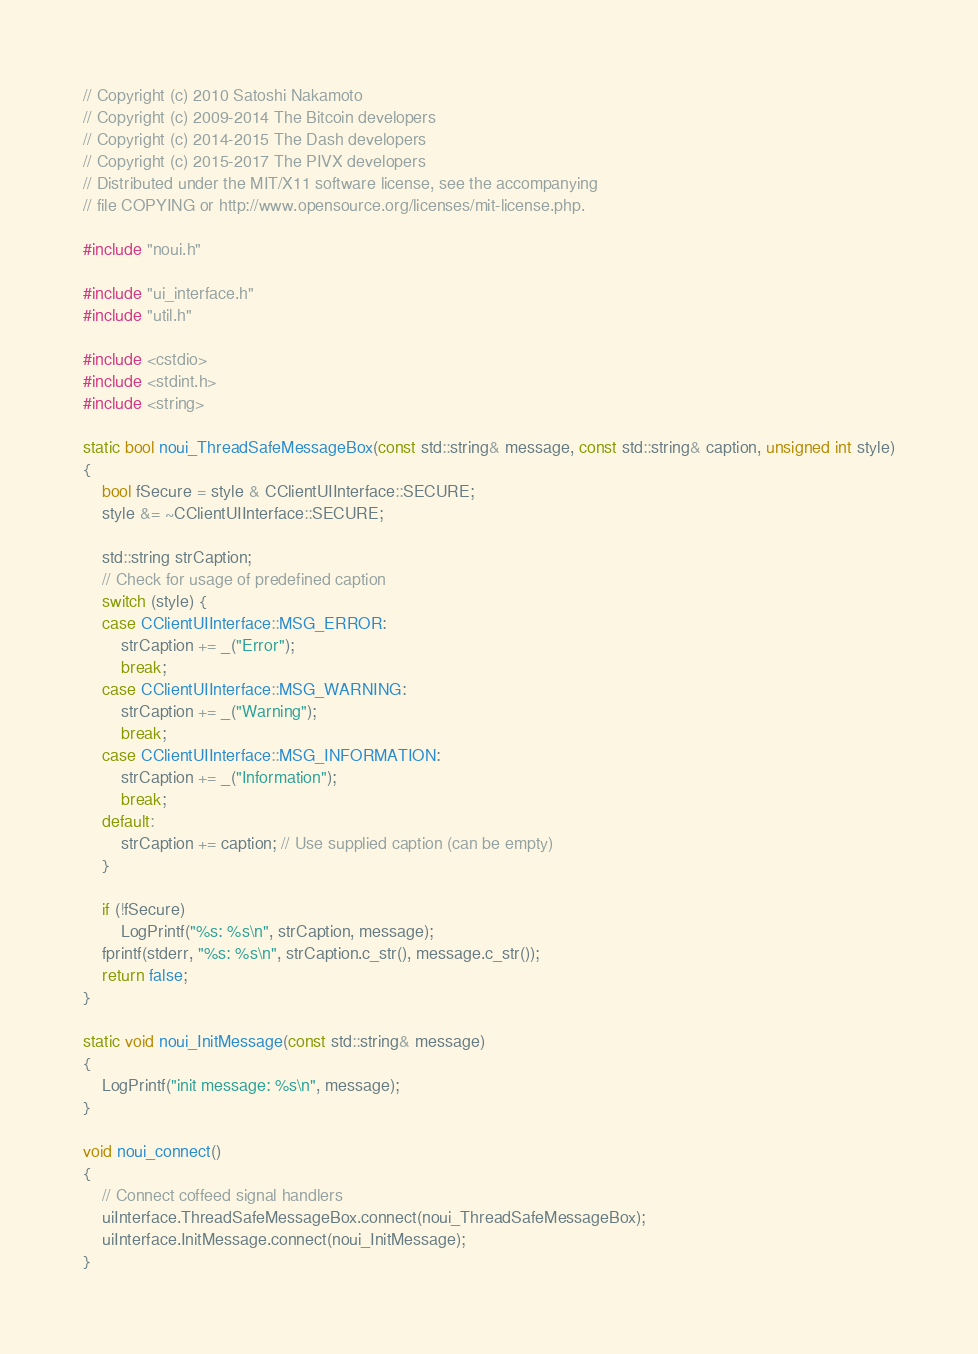<code> <loc_0><loc_0><loc_500><loc_500><_C++_>// Copyright (c) 2010 Satoshi Nakamoto
// Copyright (c) 2009-2014 The Bitcoin developers
// Copyright (c) 2014-2015 The Dash developers
// Copyright (c) 2015-2017 The PIVX developers
// Distributed under the MIT/X11 software license, see the accompanying
// file COPYING or http://www.opensource.org/licenses/mit-license.php.

#include "noui.h"

#include "ui_interface.h"
#include "util.h"

#include <cstdio>
#include <stdint.h>
#include <string>

static bool noui_ThreadSafeMessageBox(const std::string& message, const std::string& caption, unsigned int style)
{
    bool fSecure = style & CClientUIInterface::SECURE;
    style &= ~CClientUIInterface::SECURE;

    std::string strCaption;
    // Check for usage of predefined caption
    switch (style) {
    case CClientUIInterface::MSG_ERROR:
        strCaption += _("Error");
        break;
    case CClientUIInterface::MSG_WARNING:
        strCaption += _("Warning");
        break;
    case CClientUIInterface::MSG_INFORMATION:
        strCaption += _("Information");
        break;
    default:
        strCaption += caption; // Use supplied caption (can be empty)
    }

    if (!fSecure)
        LogPrintf("%s: %s\n", strCaption, message);
    fprintf(stderr, "%s: %s\n", strCaption.c_str(), message.c_str());
    return false;
}

static void noui_InitMessage(const std::string& message)
{
    LogPrintf("init message: %s\n", message);
}

void noui_connect()
{
    // Connect coffeed signal handlers
    uiInterface.ThreadSafeMessageBox.connect(noui_ThreadSafeMessageBox);
    uiInterface.InitMessage.connect(noui_InitMessage);
}
</code> 